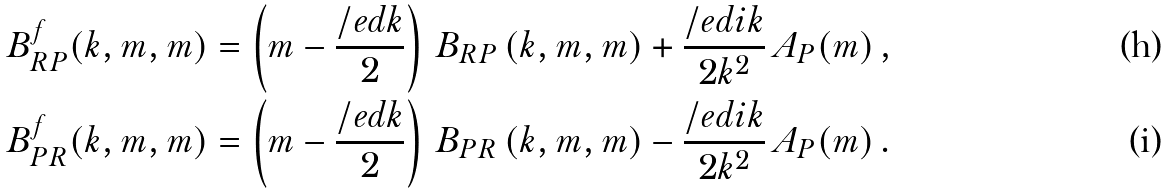<formula> <loc_0><loc_0><loc_500><loc_500>B ^ { f } _ { R P } ( k , m , m ) & = \left ( m - \frac { \slash e d { k } } { 2 } \right ) \, B _ { R P } \left ( k , m , m \right ) + \frac { \slash e d { i k } } { 2 k ^ { 2 } } \, A _ { P } ( m ) \, , \\ B ^ { f } _ { P R } ( k , m , m ) & = \left ( m - \frac { \slash e d { k } } { 2 } \right ) \, B _ { P R } \left ( k , m , m \right ) - \frac { \slash e d { i k } } { 2 k ^ { 2 } } \, A _ { P } ( m ) \, .</formula> 